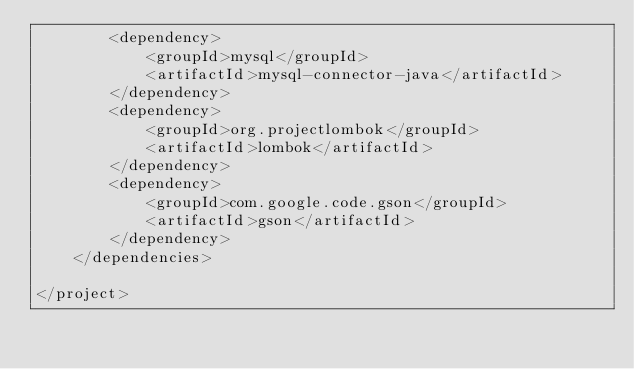<code> <loc_0><loc_0><loc_500><loc_500><_XML_>        <dependency>
            <groupId>mysql</groupId>
            <artifactId>mysql-connector-java</artifactId>
        </dependency>
        <dependency>
            <groupId>org.projectlombok</groupId>
            <artifactId>lombok</artifactId>
        </dependency>
        <dependency>
            <groupId>com.google.code.gson</groupId>
            <artifactId>gson</artifactId>
        </dependency>
    </dependencies>

</project></code> 